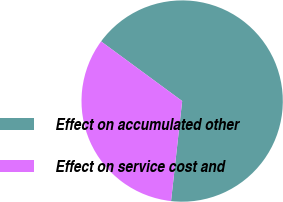Convert chart to OTSL. <chart><loc_0><loc_0><loc_500><loc_500><pie_chart><fcel>Effect on accumulated other<fcel>Effect on service cost and<nl><fcel>66.67%<fcel>33.33%<nl></chart> 